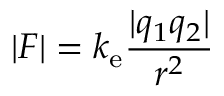Convert formula to latex. <formula><loc_0><loc_0><loc_500><loc_500>| F | = k _ { e } { \frac { | q _ { 1 } q _ { 2 } | } { r ^ { 2 } } }</formula> 